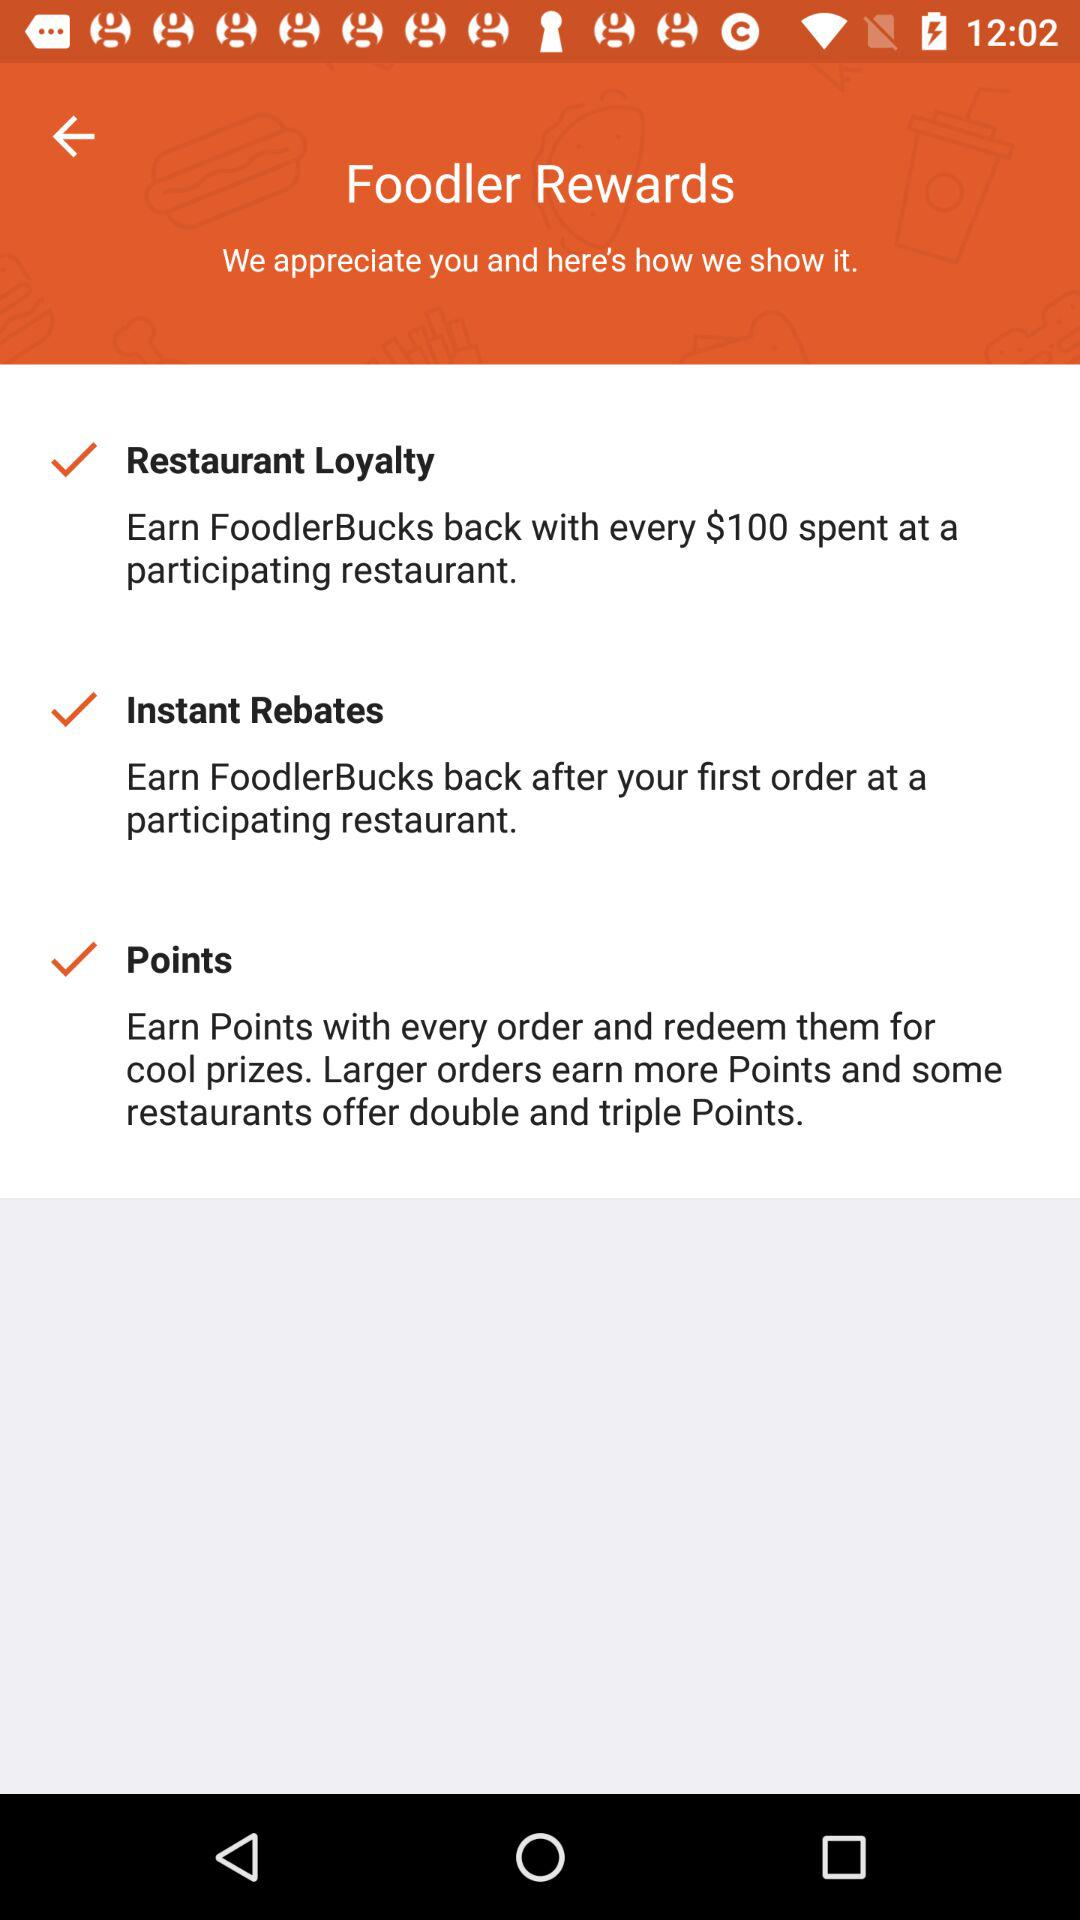How many rewards programs are there?
Answer the question using a single word or phrase. 3 